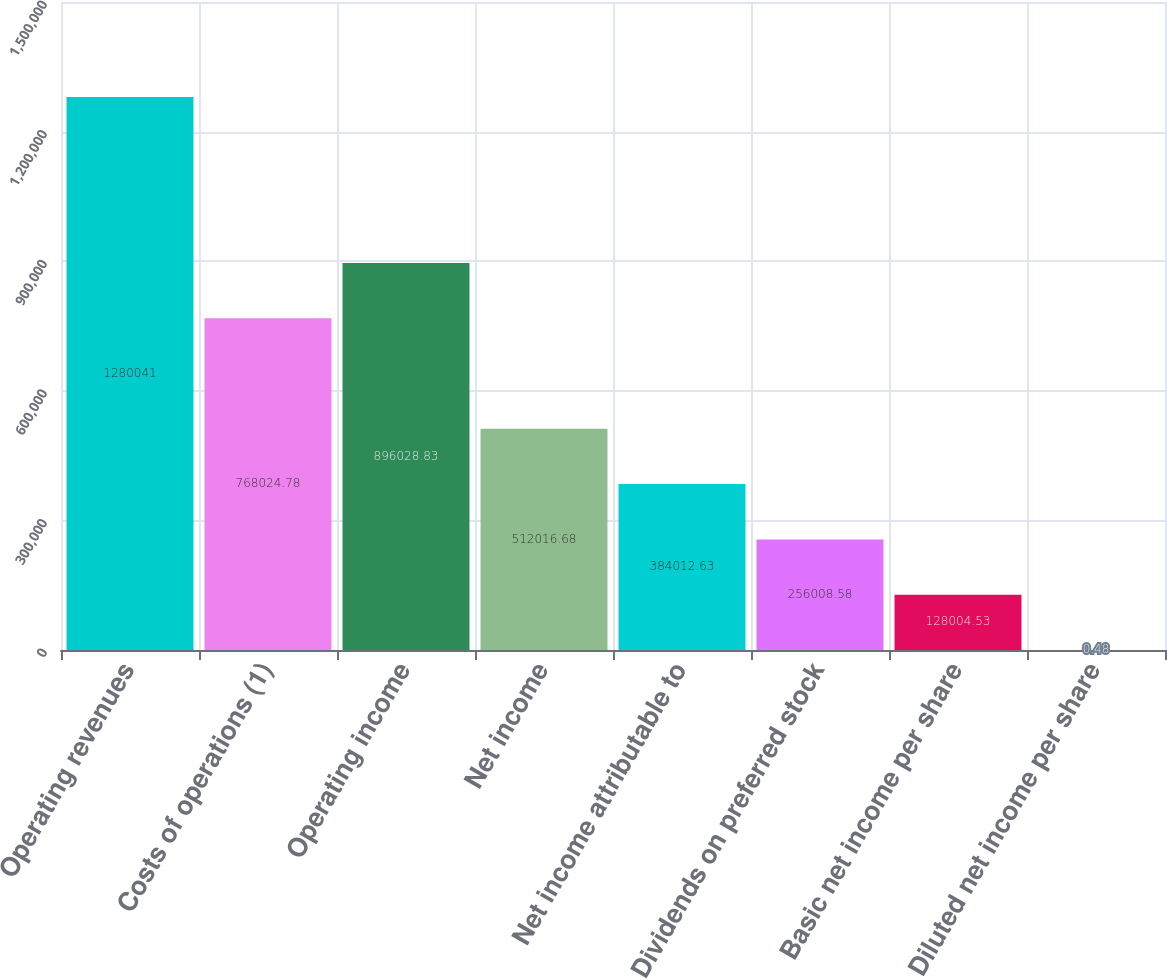<chart> <loc_0><loc_0><loc_500><loc_500><bar_chart><fcel>Operating revenues<fcel>Costs of operations (1)<fcel>Operating income<fcel>Net income<fcel>Net income attributable to<fcel>Dividends on preferred stock<fcel>Basic net income per share<fcel>Diluted net income per share<nl><fcel>1.28004e+06<fcel>768025<fcel>896029<fcel>512017<fcel>384013<fcel>256009<fcel>128005<fcel>0.48<nl></chart> 